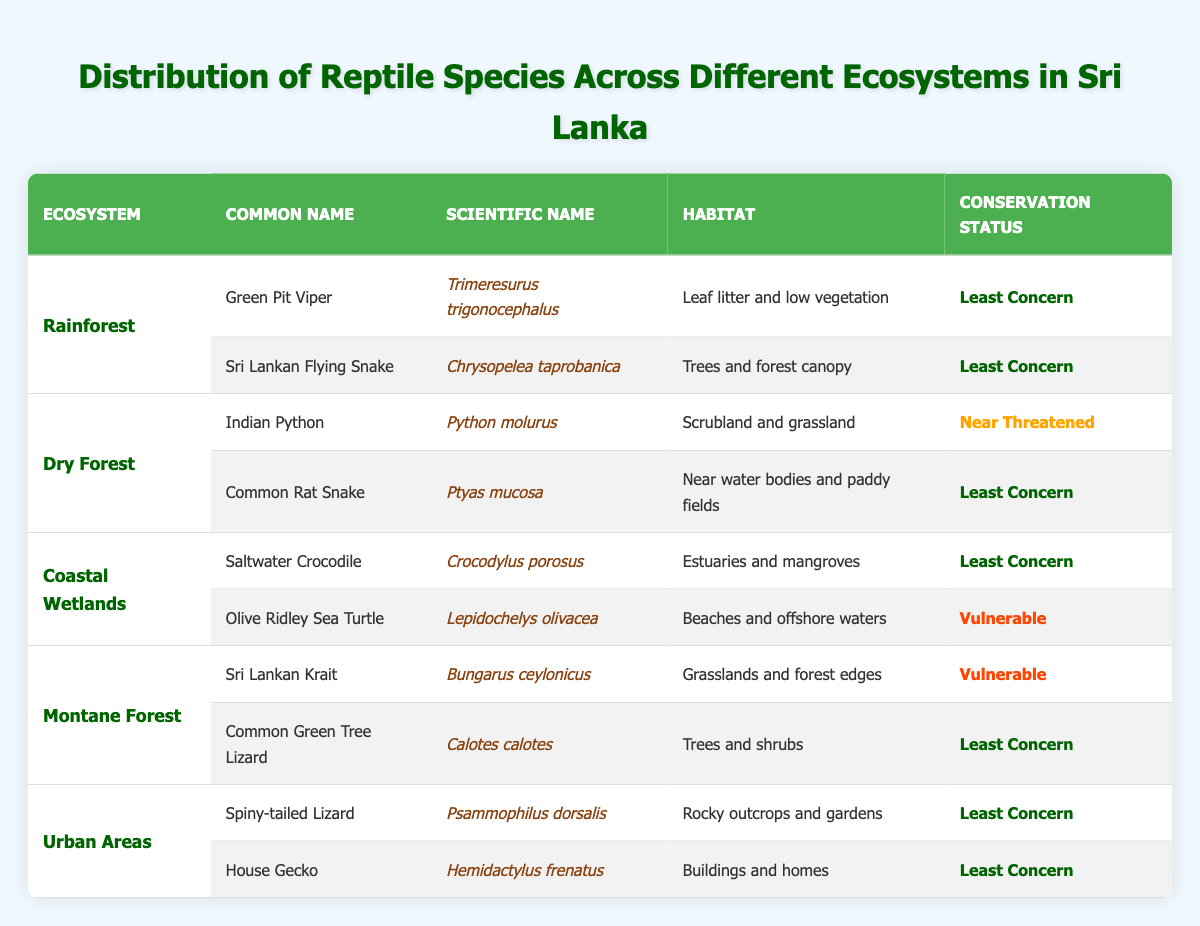What are the conservation statuses of reptiles in the Rainforest ecosystem? In the Rainforest ecosystem, there are two reptiles listed: the Green Pit Viper and the Sri Lankan Flying Snake. Both have a conservation status of "Least Concern."
Answer: Least Concern Which reptile in the Dry Forest ecosystem has a conservation status of Near Threatened? The Indian Python in the Dry Forest ecosystem has a conservation status of "Near Threatened."
Answer: Indian Python How many reptiles are listed in the Coastal Wetlands ecosystem? In the Coastal Wetlands ecosystem, there are two reptiles listed: the Saltwater Crocodile and the Olive Ridley Sea Turtle.
Answer: 2 Are there any reptiles with a conservation status of Vulnerable in Urban Areas? No, all reptiles in Urban Areas, including the Spiny-tailed Lizard and House Gecko, have a conservation status of "Least Concern."
Answer: No Which ecosystem has the Sri Lankan Krait, and what is its habitat? The Sri Lankan Krait is found in the Montane Forest ecosystem, and its habitat is grasslands and forest edges.
Answer: Montane Forest; grasslands and forest edges What is the total number of reptiles listed with a conservation status of Least Concern? By counting all reptiles in the table, six out of ten listed species have a conservation status of "Least Concern."
Answer: 6 Is the Olive Ridley Sea Turtle found in the Dry Forest ecosystem? No, the Olive Ridley Sea Turtle is listed under the Coastal Wetlands ecosystem, not the Dry Forest.
Answer: No Which reptile occupies trees and shrubs, and what is its conservation status? The Common Green Tree Lizard occupies trees and shrubs, and its conservation status is "Least Concern."
Answer: Least Concern Among the listed reptiles, which has the highest conservation status concern? The Olive Ridley Sea Turtle and the Sri Lankan Krait are both categorized as "Vulnerable," which is a higher concern than the statuses of the others.
Answer: Olive Ridley Sea Turtle and Sri Lankan Krait How many reptiles are there in the Montane Forest ecosystem, and what are their conservation statuses? The Montane Forest ecosystem has two reptiles: the Sri Lankan Krait with a status of "Vulnerable" and the Common Green Tree Lizard with a status of "Least Concern."
Answer: 2 (Sri Lankan Krait: Vulnerable; Common Green Tree Lizard: Least Concern) 